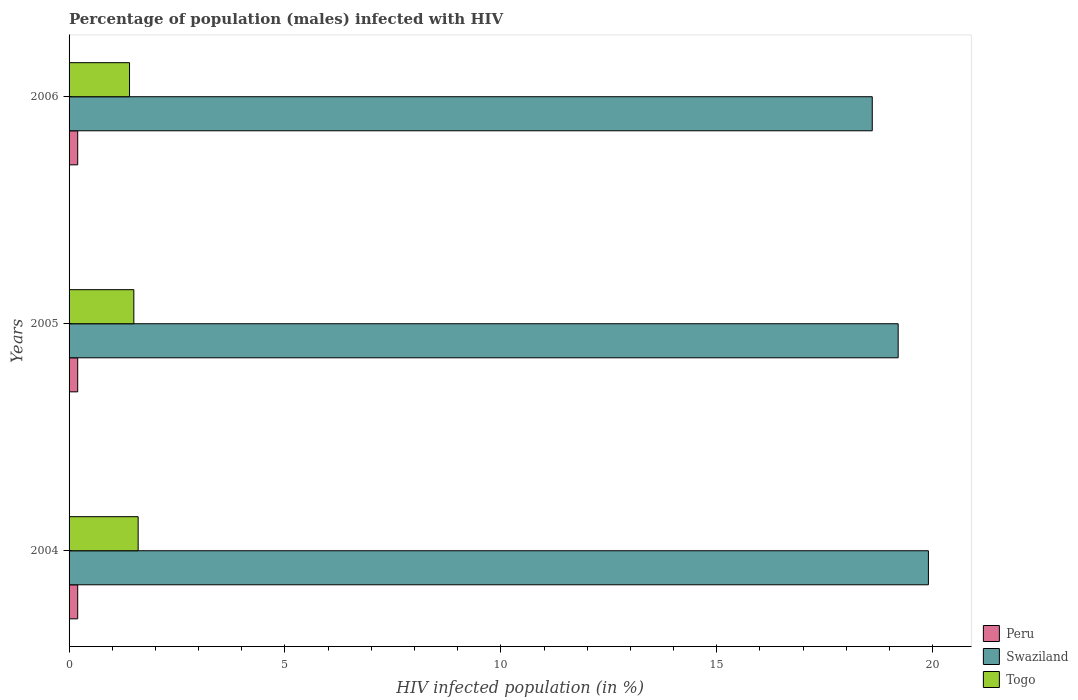How many different coloured bars are there?
Your answer should be compact. 3. Are the number of bars on each tick of the Y-axis equal?
Your response must be concise. Yes. How many bars are there on the 2nd tick from the top?
Give a very brief answer. 3. What is the label of the 1st group of bars from the top?
Your answer should be very brief. 2006. What is the percentage of HIV infected male population in Peru in 2004?
Keep it short and to the point. 0.2. In which year was the percentage of HIV infected male population in Swaziland minimum?
Make the answer very short. 2006. What is the total percentage of HIV infected male population in Peru in the graph?
Give a very brief answer. 0.6. What is the difference between the percentage of HIV infected male population in Togo in 2004 and that in 2005?
Give a very brief answer. 0.1. What is the average percentage of HIV infected male population in Swaziland per year?
Keep it short and to the point. 19.23. What is the ratio of the percentage of HIV infected male population in Togo in 2004 to that in 2006?
Your response must be concise. 1.14. Is the percentage of HIV infected male population in Peru in 2004 less than that in 2006?
Keep it short and to the point. No. What is the difference between the highest and the second highest percentage of HIV infected male population in Togo?
Keep it short and to the point. 0.1. What is the difference between the highest and the lowest percentage of HIV infected male population in Togo?
Make the answer very short. 0.2. In how many years, is the percentage of HIV infected male population in Togo greater than the average percentage of HIV infected male population in Togo taken over all years?
Your answer should be compact. 1. What does the 1st bar from the top in 2006 represents?
Provide a succinct answer. Togo. What does the 1st bar from the bottom in 2006 represents?
Offer a terse response. Peru. Is it the case that in every year, the sum of the percentage of HIV infected male population in Peru and percentage of HIV infected male population in Togo is greater than the percentage of HIV infected male population in Swaziland?
Make the answer very short. No. How many bars are there?
Your answer should be very brief. 9. Are all the bars in the graph horizontal?
Offer a terse response. Yes. What is the difference between two consecutive major ticks on the X-axis?
Make the answer very short. 5. Are the values on the major ticks of X-axis written in scientific E-notation?
Make the answer very short. No. Does the graph contain any zero values?
Offer a terse response. No. How many legend labels are there?
Your answer should be compact. 3. What is the title of the graph?
Give a very brief answer. Percentage of population (males) infected with HIV. What is the label or title of the X-axis?
Make the answer very short. HIV infected population (in %). What is the label or title of the Y-axis?
Offer a very short reply. Years. What is the HIV infected population (in %) of Peru in 2004?
Give a very brief answer. 0.2. What is the HIV infected population (in %) of Peru in 2005?
Your answer should be compact. 0.2. What is the HIV infected population (in %) of Swaziland in 2005?
Your answer should be compact. 19.2. What is the HIV infected population (in %) in Swaziland in 2006?
Provide a short and direct response. 18.6. What is the HIV infected population (in %) in Togo in 2006?
Offer a very short reply. 1.4. Across all years, what is the maximum HIV infected population (in %) in Togo?
Your answer should be compact. 1.6. Across all years, what is the minimum HIV infected population (in %) of Peru?
Your answer should be compact. 0.2. Across all years, what is the minimum HIV infected population (in %) in Swaziland?
Ensure brevity in your answer.  18.6. What is the total HIV infected population (in %) in Peru in the graph?
Your answer should be compact. 0.6. What is the total HIV infected population (in %) in Swaziland in the graph?
Offer a terse response. 57.7. What is the total HIV infected population (in %) of Togo in the graph?
Give a very brief answer. 4.5. What is the difference between the HIV infected population (in %) of Swaziland in 2004 and that in 2005?
Give a very brief answer. 0.7. What is the difference between the HIV infected population (in %) in Togo in 2004 and that in 2006?
Offer a very short reply. 0.2. What is the difference between the HIV infected population (in %) of Peru in 2005 and that in 2006?
Provide a short and direct response. 0. What is the difference between the HIV infected population (in %) of Swaziland in 2005 and that in 2006?
Provide a short and direct response. 0.6. What is the difference between the HIV infected population (in %) of Peru in 2004 and the HIV infected population (in %) of Togo in 2005?
Provide a short and direct response. -1.3. What is the difference between the HIV infected population (in %) of Swaziland in 2004 and the HIV infected population (in %) of Togo in 2005?
Your answer should be compact. 18.4. What is the difference between the HIV infected population (in %) in Peru in 2004 and the HIV infected population (in %) in Swaziland in 2006?
Make the answer very short. -18.4. What is the difference between the HIV infected population (in %) in Peru in 2004 and the HIV infected population (in %) in Togo in 2006?
Give a very brief answer. -1.2. What is the difference between the HIV infected population (in %) of Swaziland in 2004 and the HIV infected population (in %) of Togo in 2006?
Offer a terse response. 18.5. What is the difference between the HIV infected population (in %) in Peru in 2005 and the HIV infected population (in %) in Swaziland in 2006?
Give a very brief answer. -18.4. What is the difference between the HIV infected population (in %) of Peru in 2005 and the HIV infected population (in %) of Togo in 2006?
Provide a succinct answer. -1.2. What is the difference between the HIV infected population (in %) of Swaziland in 2005 and the HIV infected population (in %) of Togo in 2006?
Ensure brevity in your answer.  17.8. What is the average HIV infected population (in %) in Swaziland per year?
Your answer should be very brief. 19.23. In the year 2004, what is the difference between the HIV infected population (in %) in Peru and HIV infected population (in %) in Swaziland?
Your answer should be compact. -19.7. In the year 2004, what is the difference between the HIV infected population (in %) in Peru and HIV infected population (in %) in Togo?
Give a very brief answer. -1.4. In the year 2005, what is the difference between the HIV infected population (in %) of Peru and HIV infected population (in %) of Togo?
Give a very brief answer. -1.3. In the year 2006, what is the difference between the HIV infected population (in %) in Peru and HIV infected population (in %) in Swaziland?
Offer a very short reply. -18.4. What is the ratio of the HIV infected population (in %) of Peru in 2004 to that in 2005?
Make the answer very short. 1. What is the ratio of the HIV infected population (in %) of Swaziland in 2004 to that in 2005?
Offer a very short reply. 1.04. What is the ratio of the HIV infected population (in %) in Togo in 2004 to that in 2005?
Your answer should be very brief. 1.07. What is the ratio of the HIV infected population (in %) in Swaziland in 2004 to that in 2006?
Provide a succinct answer. 1.07. What is the ratio of the HIV infected population (in %) of Swaziland in 2005 to that in 2006?
Give a very brief answer. 1.03. What is the ratio of the HIV infected population (in %) of Togo in 2005 to that in 2006?
Provide a succinct answer. 1.07. What is the difference between the highest and the second highest HIV infected population (in %) in Peru?
Provide a succinct answer. 0. What is the difference between the highest and the lowest HIV infected population (in %) in Togo?
Ensure brevity in your answer.  0.2. 